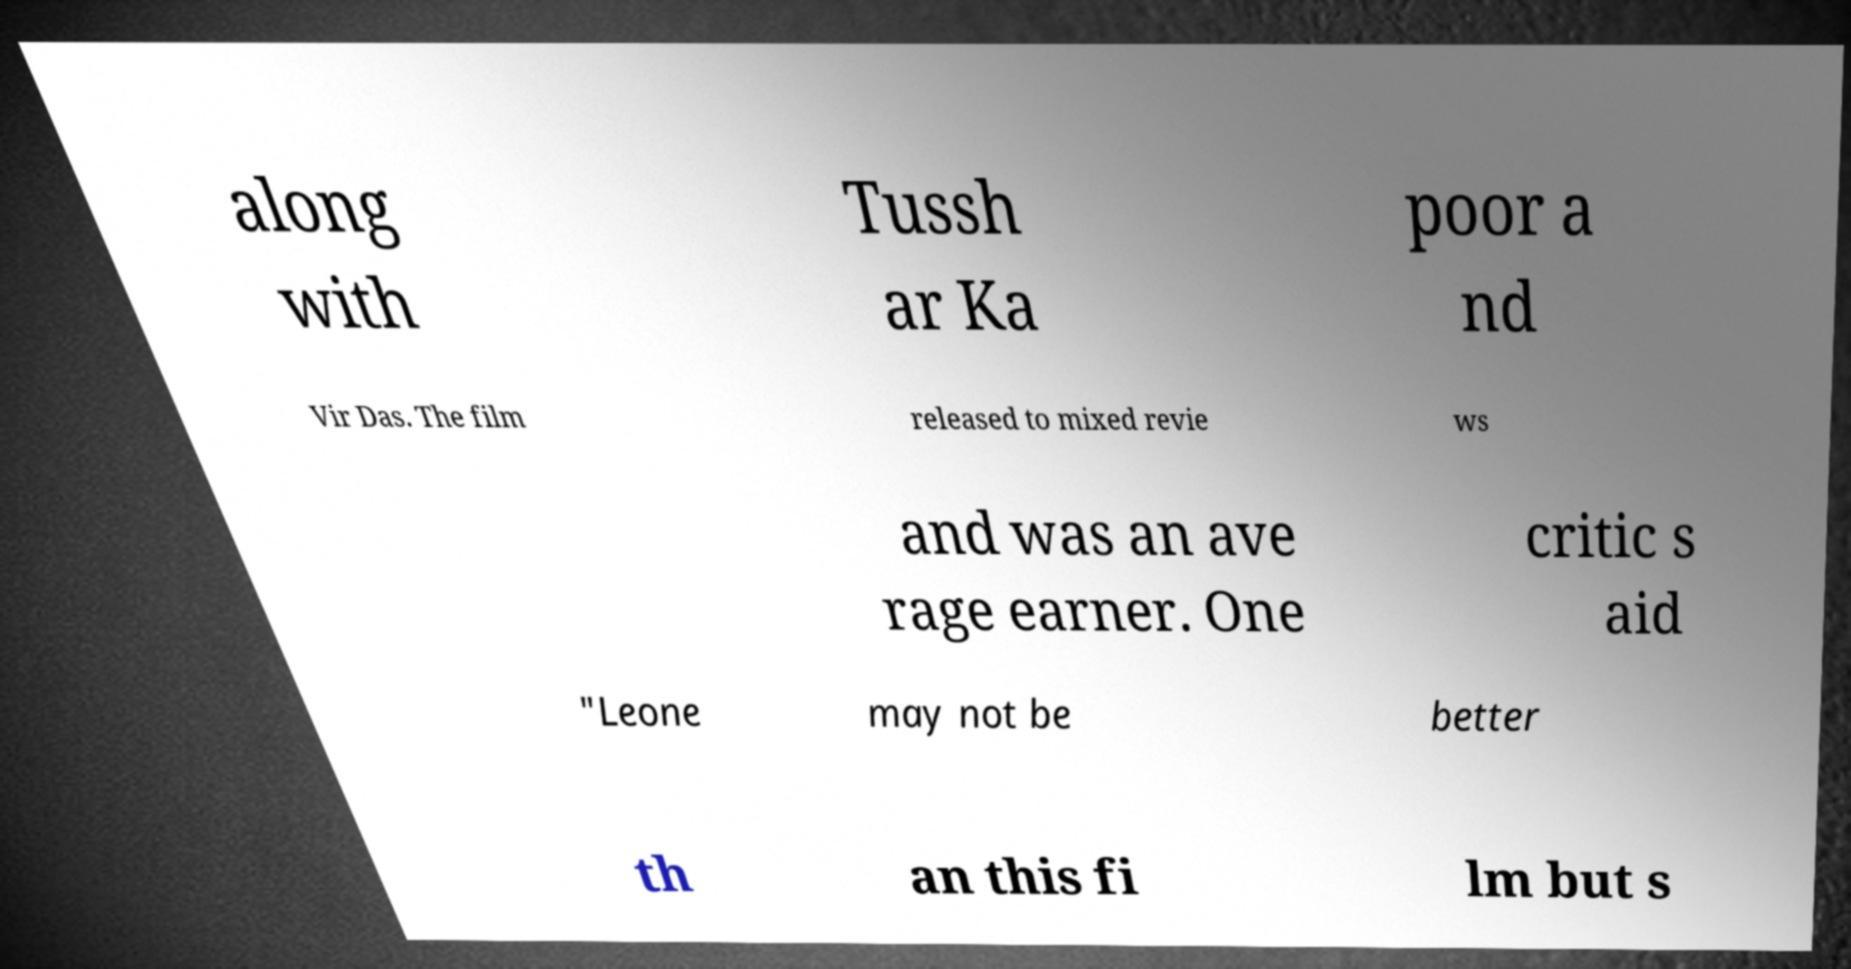Please identify and transcribe the text found in this image. along with Tussh ar Ka poor a nd Vir Das. The film released to mixed revie ws and was an ave rage earner. One critic s aid "Leone may not be better th an this fi lm but s 